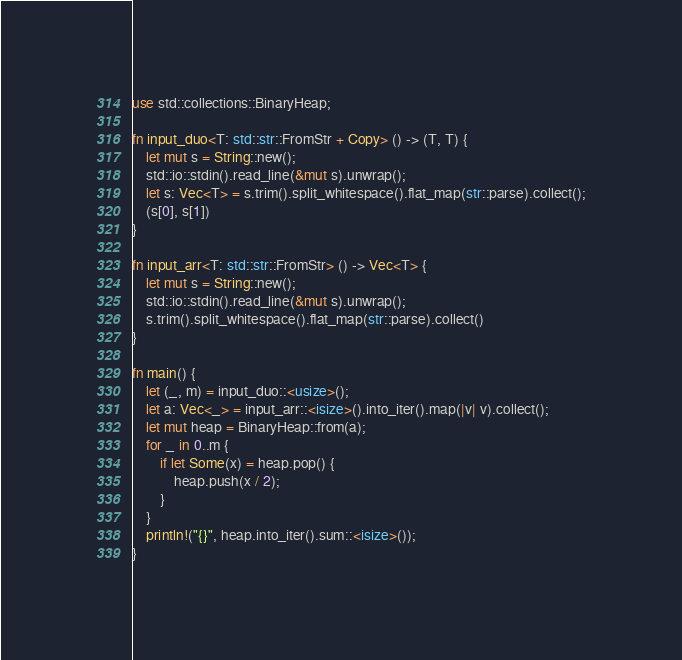Convert code to text. <code><loc_0><loc_0><loc_500><loc_500><_Rust_>use std::collections::BinaryHeap;

fn input_duo<T: std::str::FromStr + Copy> () -> (T, T) {
    let mut s = String::new();
    std::io::stdin().read_line(&mut s).unwrap();
    let s: Vec<T> = s.trim().split_whitespace().flat_map(str::parse).collect();
    (s[0], s[1])
}

fn input_arr<T: std::str::FromStr> () -> Vec<T> {
    let mut s = String::new();
    std::io::stdin().read_line(&mut s).unwrap();
    s.trim().split_whitespace().flat_map(str::parse).collect()
}

fn main() {
    let (_, m) = input_duo::<usize>();
    let a: Vec<_> = input_arr::<isize>().into_iter().map(|v| v).collect();
    let mut heap = BinaryHeap::from(a);
    for _ in 0..m {
        if let Some(x) = heap.pop() {
            heap.push(x / 2);
        }
    }
    println!("{}", heap.into_iter().sum::<isize>());
}
</code> 